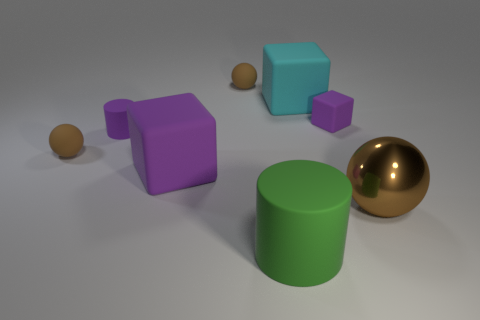Is there anything else that is made of the same material as the big brown object?
Your answer should be very brief. No. The sphere right of the cyan rubber cube is what color?
Offer a very short reply. Brown. Does the brown rubber ball that is in front of the large cyan rubber block have the same size as the matte object in front of the shiny sphere?
Offer a terse response. No. How many objects are either rubber blocks or big metallic spheres?
Give a very brief answer. 4. What is the tiny brown sphere that is in front of the small thing that is behind the big cyan rubber block made of?
Offer a terse response. Rubber. How many other matte objects are the same shape as the green object?
Make the answer very short. 1. Are there any tiny matte cylinders that have the same color as the small matte block?
Your answer should be very brief. Yes. What number of things are either small objects that are behind the small purple matte cylinder or things behind the big brown object?
Your answer should be very brief. 6. There is a tiny purple cube that is on the right side of the large cyan matte object; is there a big purple rubber cube behind it?
Give a very brief answer. No. There is a cyan rubber object that is the same size as the brown metallic ball; what is its shape?
Make the answer very short. Cube. 